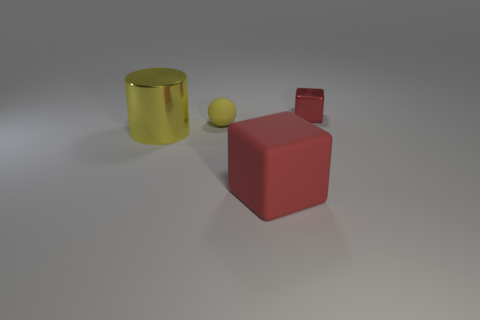Add 3 tiny red metallic cubes. How many objects exist? 7 Subtract all cylinders. How many objects are left? 3 Add 4 small things. How many small things are left? 6 Add 2 large green blocks. How many large green blocks exist? 2 Subtract 0 purple spheres. How many objects are left? 4 Subtract all large red matte things. Subtract all matte things. How many objects are left? 1 